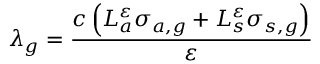Convert formula to latex. <formula><loc_0><loc_0><loc_500><loc_500>\lambda _ { g } = \frac { c \left ( L _ { a } ^ { \varepsilon } \sigma _ { a , g } + L _ { s } ^ { \varepsilon } \sigma _ { s , g } \right ) } { \varepsilon }</formula> 